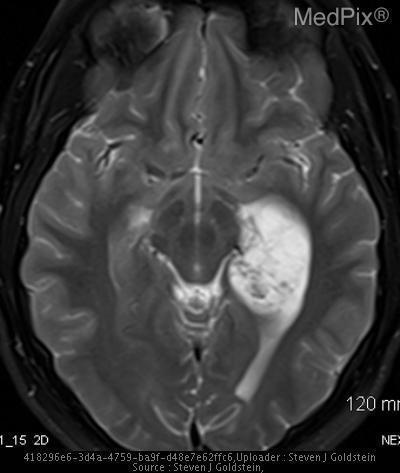How would you describe the mass?
Quick response, please. Isointense. What are the characteristics of the mass?
Concise answer only. Isointense. Is there a fracture of the skull?
Keep it brief. No. What is the location of the mass?
Keep it brief. Left temporal horn. Where is the mass?
Short answer required. Left temporal horn. Are there other abnormalities besides the mass in the temporal horn?
Answer briefly. Yes. Besides the mass in the temporal horn, are there other enhancements in the image?
Keep it brief. Yes. 